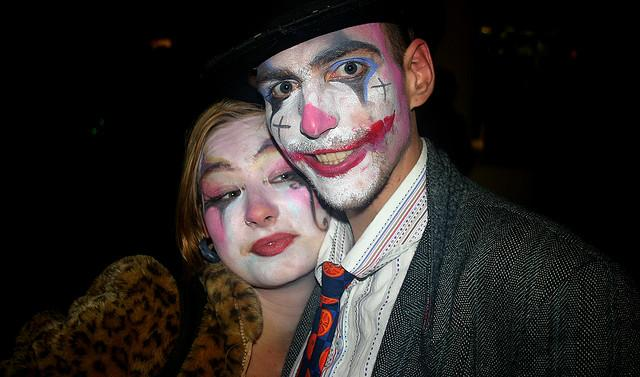What is the red thing near the man's mouth? Please explain your reasoning. paint. The man has red paint by the sides of his mouth to make it look like he has a really wide smile. 